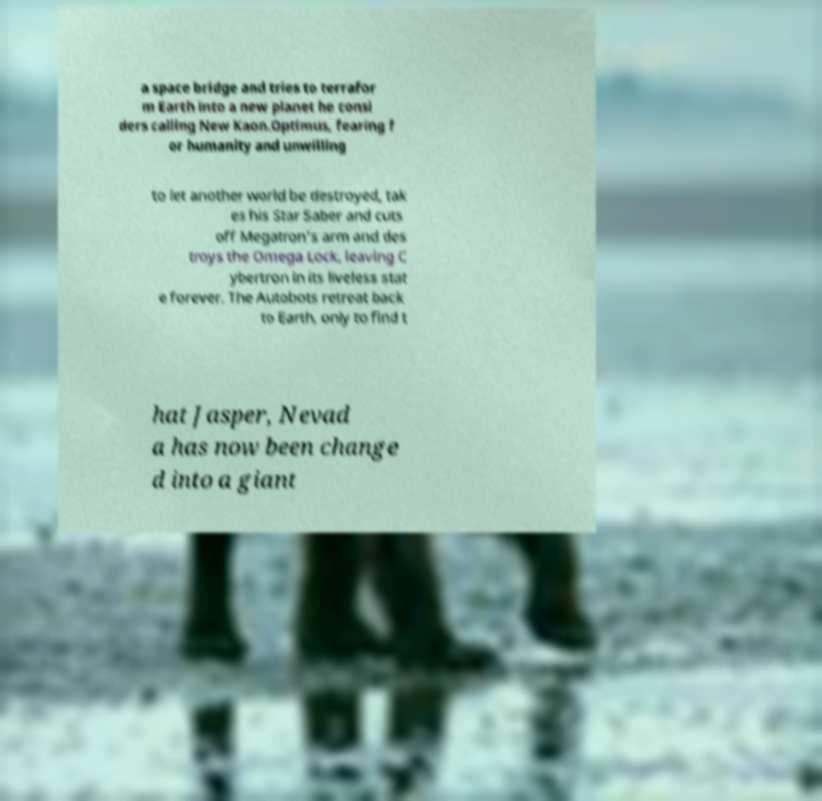Please identify and transcribe the text found in this image. a space bridge and tries to terrafor m Earth into a new planet he consi ders calling New Kaon.Optimus, fearing f or humanity and unwilling to let another world be destroyed, tak es his Star Saber and cuts off Megatron's arm and des troys the Omega Lock, leaving C ybertron in its liveless stat e forever. The Autobots retreat back to Earth, only to find t hat Jasper, Nevad a has now been change d into a giant 